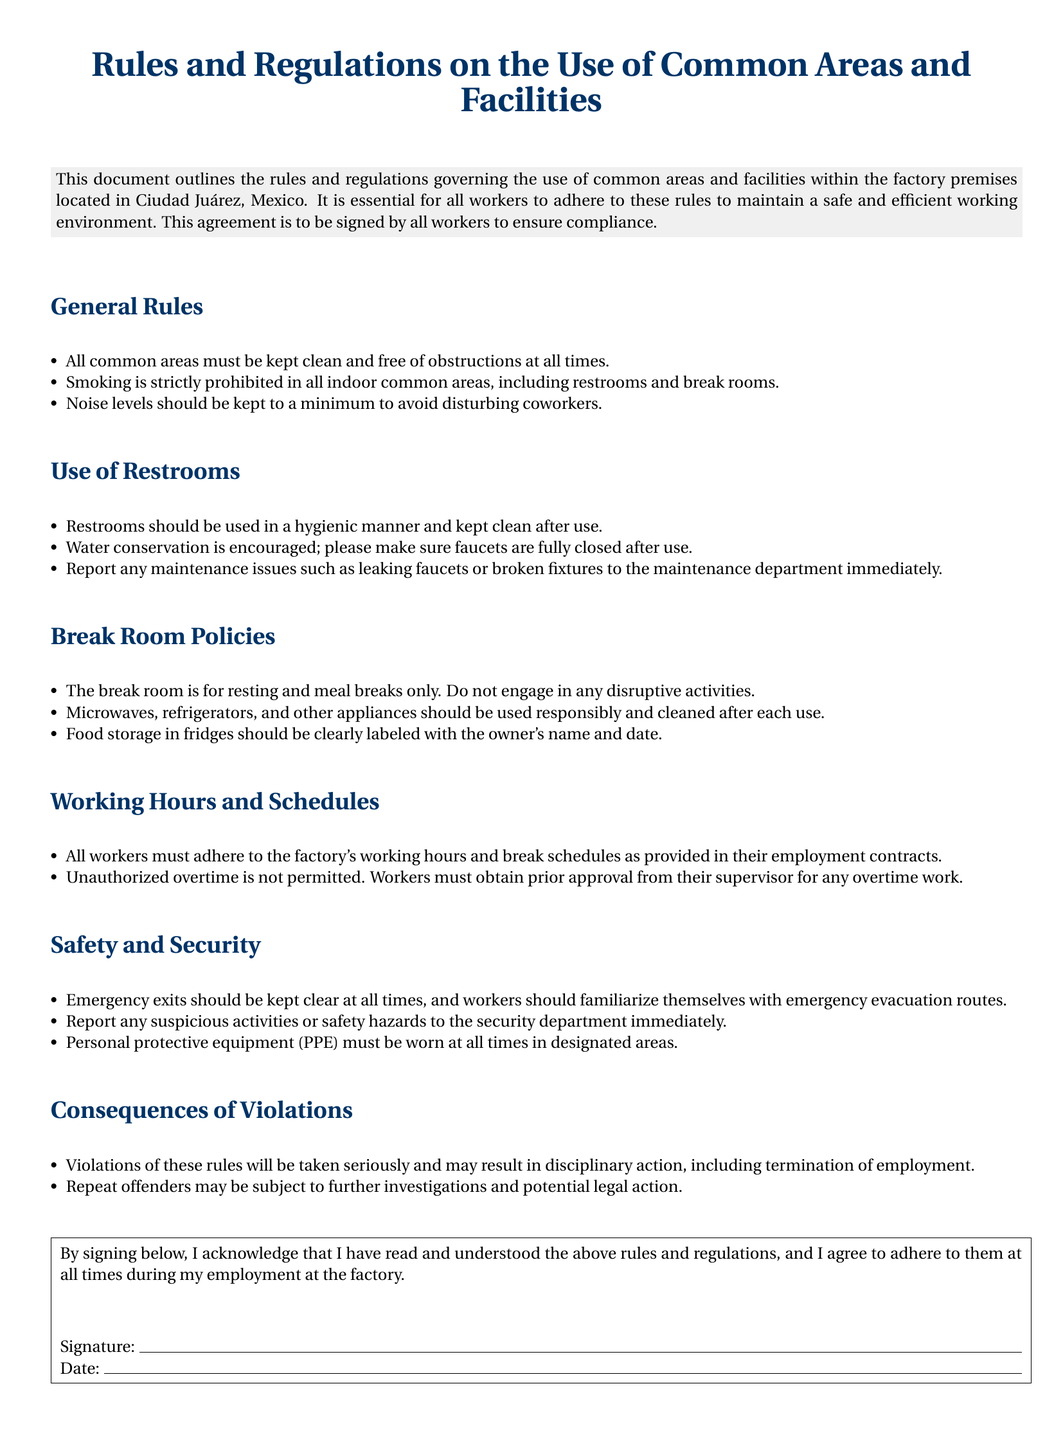What is the title of the document? The title outlines the main focus of the document regarding rules for common areas and facilities.
Answer: Rules and Regulations on the Use of Common Areas and Facilities Where is the factory located? The document specifies the location of the factory in the introduction.
Answer: Ciudad Juárez, Mexico Are smoking and disruptive activities allowed in common areas? The document clearly states that certain behaviors are prohibited to maintain a good working environment.
Answer: No What must be done after using the break room appliances? The policies establish the need for cleanliness after use of facilities in the break room.
Answer: Cleaned after each use What should be reported to the maintenance department? The rules specify maintenance issues that need to be communicated promptly for proper action.
Answer: Leaking faucets or broken fixtures What must personal protective equipment be worn for? Safety regulations in the document indicate specific areas where PPE is required.
Answer: Designated areas What are the consequences of rule violations? The document details outcomes for infractions of these rules to ensure compliance and safety.
Answer: Disciplinary action How should food storage in fridges be labeled? The break room policies clarify that proper labeling is necessary for food storage.
Answer: Owner's name and date Is unauthorized overtime permitted? The working hours and schedules section specifies the procedure for overtime work.
Answer: No 